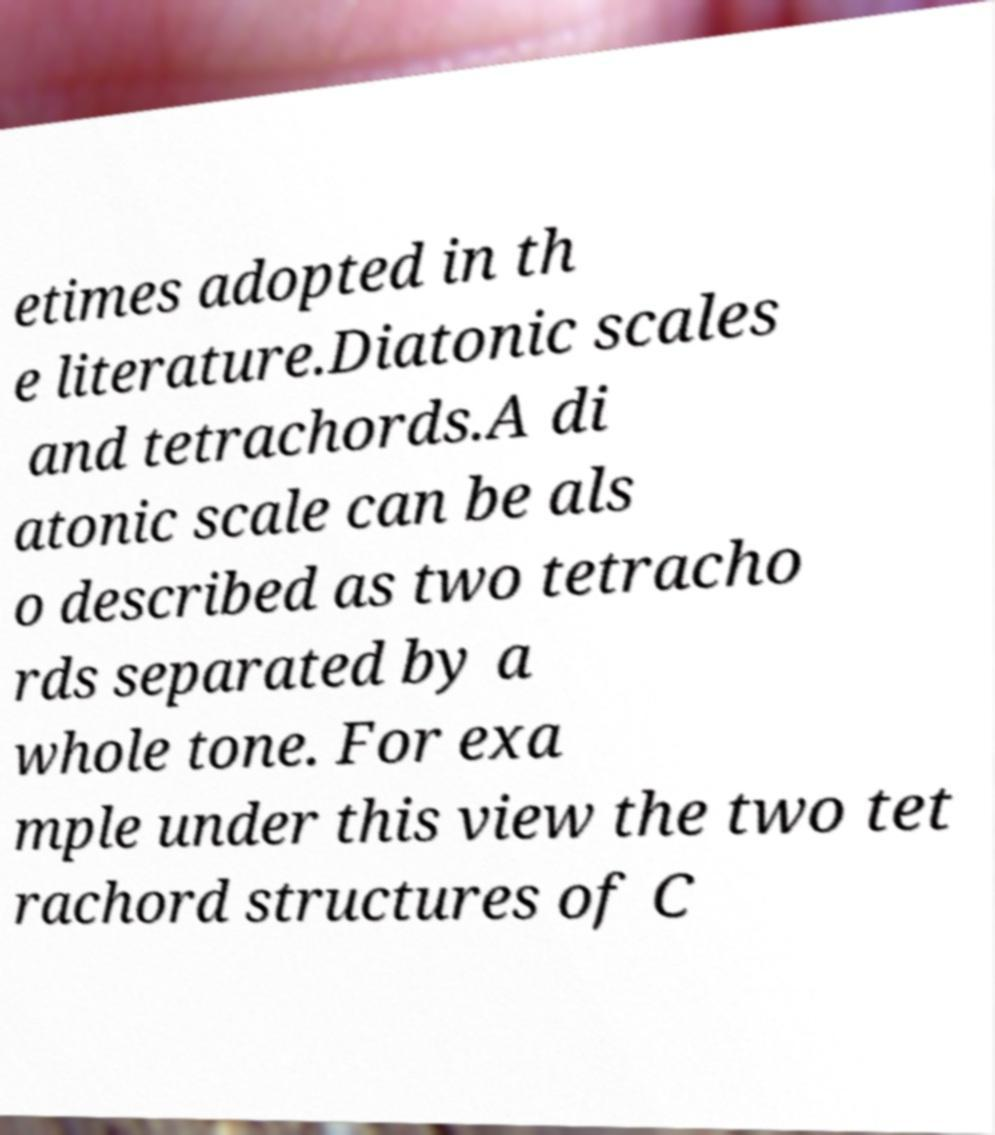There's text embedded in this image that I need extracted. Can you transcribe it verbatim? etimes adopted in th e literature.Diatonic scales and tetrachords.A di atonic scale can be als o described as two tetracho rds separated by a whole tone. For exa mple under this view the two tet rachord structures of C 